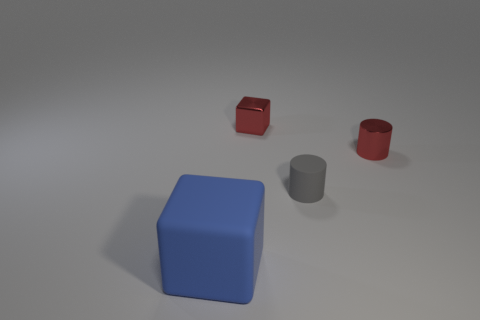There is a blue rubber block; are there any big blue matte blocks in front of it?
Your response must be concise. No. There is another metallic object that is the same shape as the tiny gray thing; what size is it?
Your answer should be compact. Small. Are there any other things that are the same size as the red cylinder?
Your answer should be very brief. Yes. Is the tiny gray matte thing the same shape as the big matte object?
Give a very brief answer. No. What size is the block left of the tiny metallic object that is to the left of the tiny matte cylinder?
Make the answer very short. Large. There is a shiny object that is the same shape as the tiny rubber thing; what color is it?
Your answer should be very brief. Red. How many small metallic cylinders have the same color as the big object?
Keep it short and to the point. 0. How big is the blue matte thing?
Your answer should be compact. Large. Is the blue thing the same size as the red shiny cylinder?
Make the answer very short. No. There is a thing that is both to the left of the tiny gray object and behind the big thing; what is its color?
Your response must be concise. Red. 